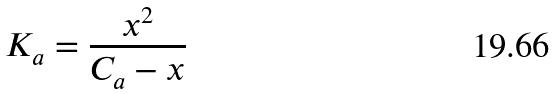Convert formula to latex. <formula><loc_0><loc_0><loc_500><loc_500>K _ { a } = \frac { x ^ { 2 } } { C _ { a } - x }</formula> 